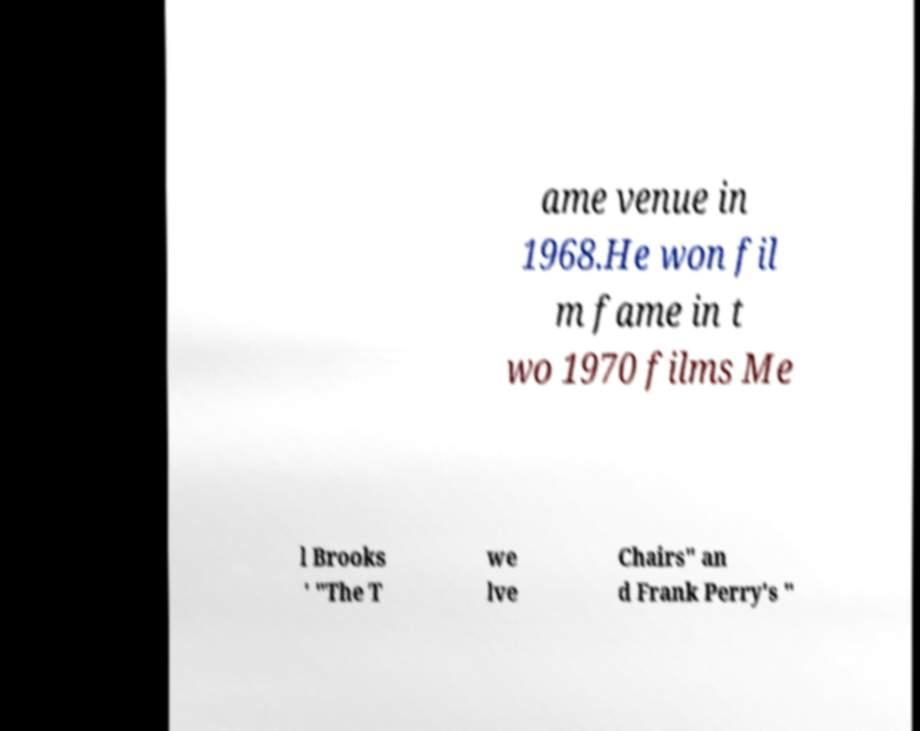Can you accurately transcribe the text from the provided image for me? ame venue in 1968.He won fil m fame in t wo 1970 films Me l Brooks ' "The T we lve Chairs" an d Frank Perry's " 